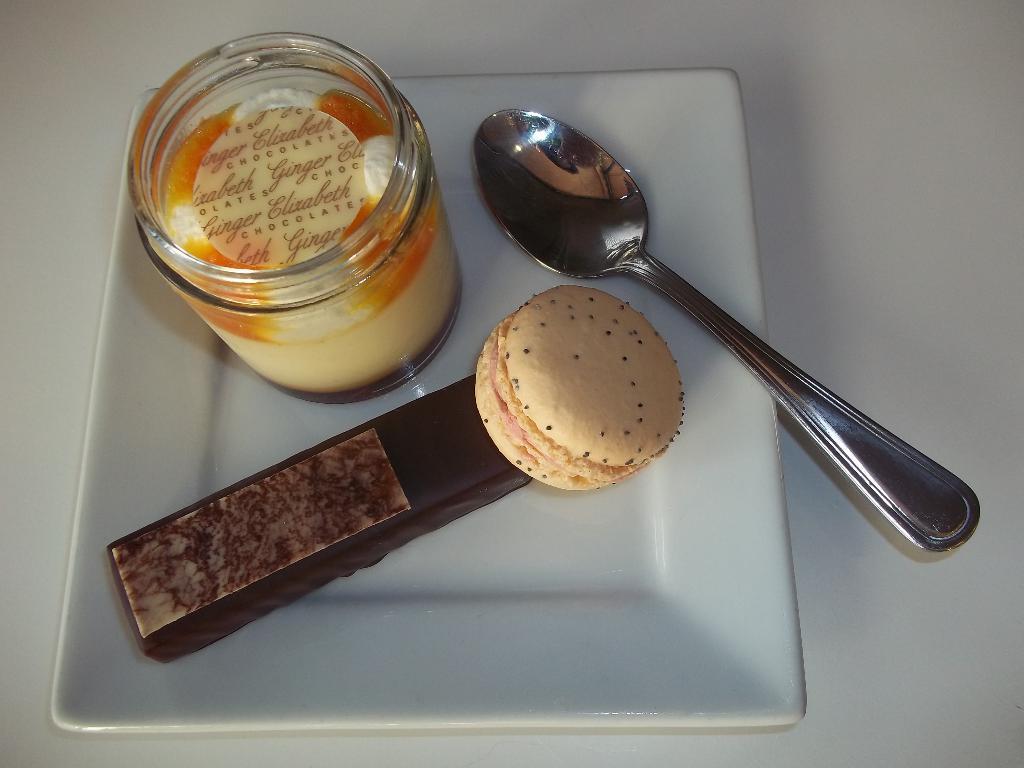Can you describe this image briefly? In this picture, we can see some food items, jar, and spoon in plate, and the plate is on an object. 